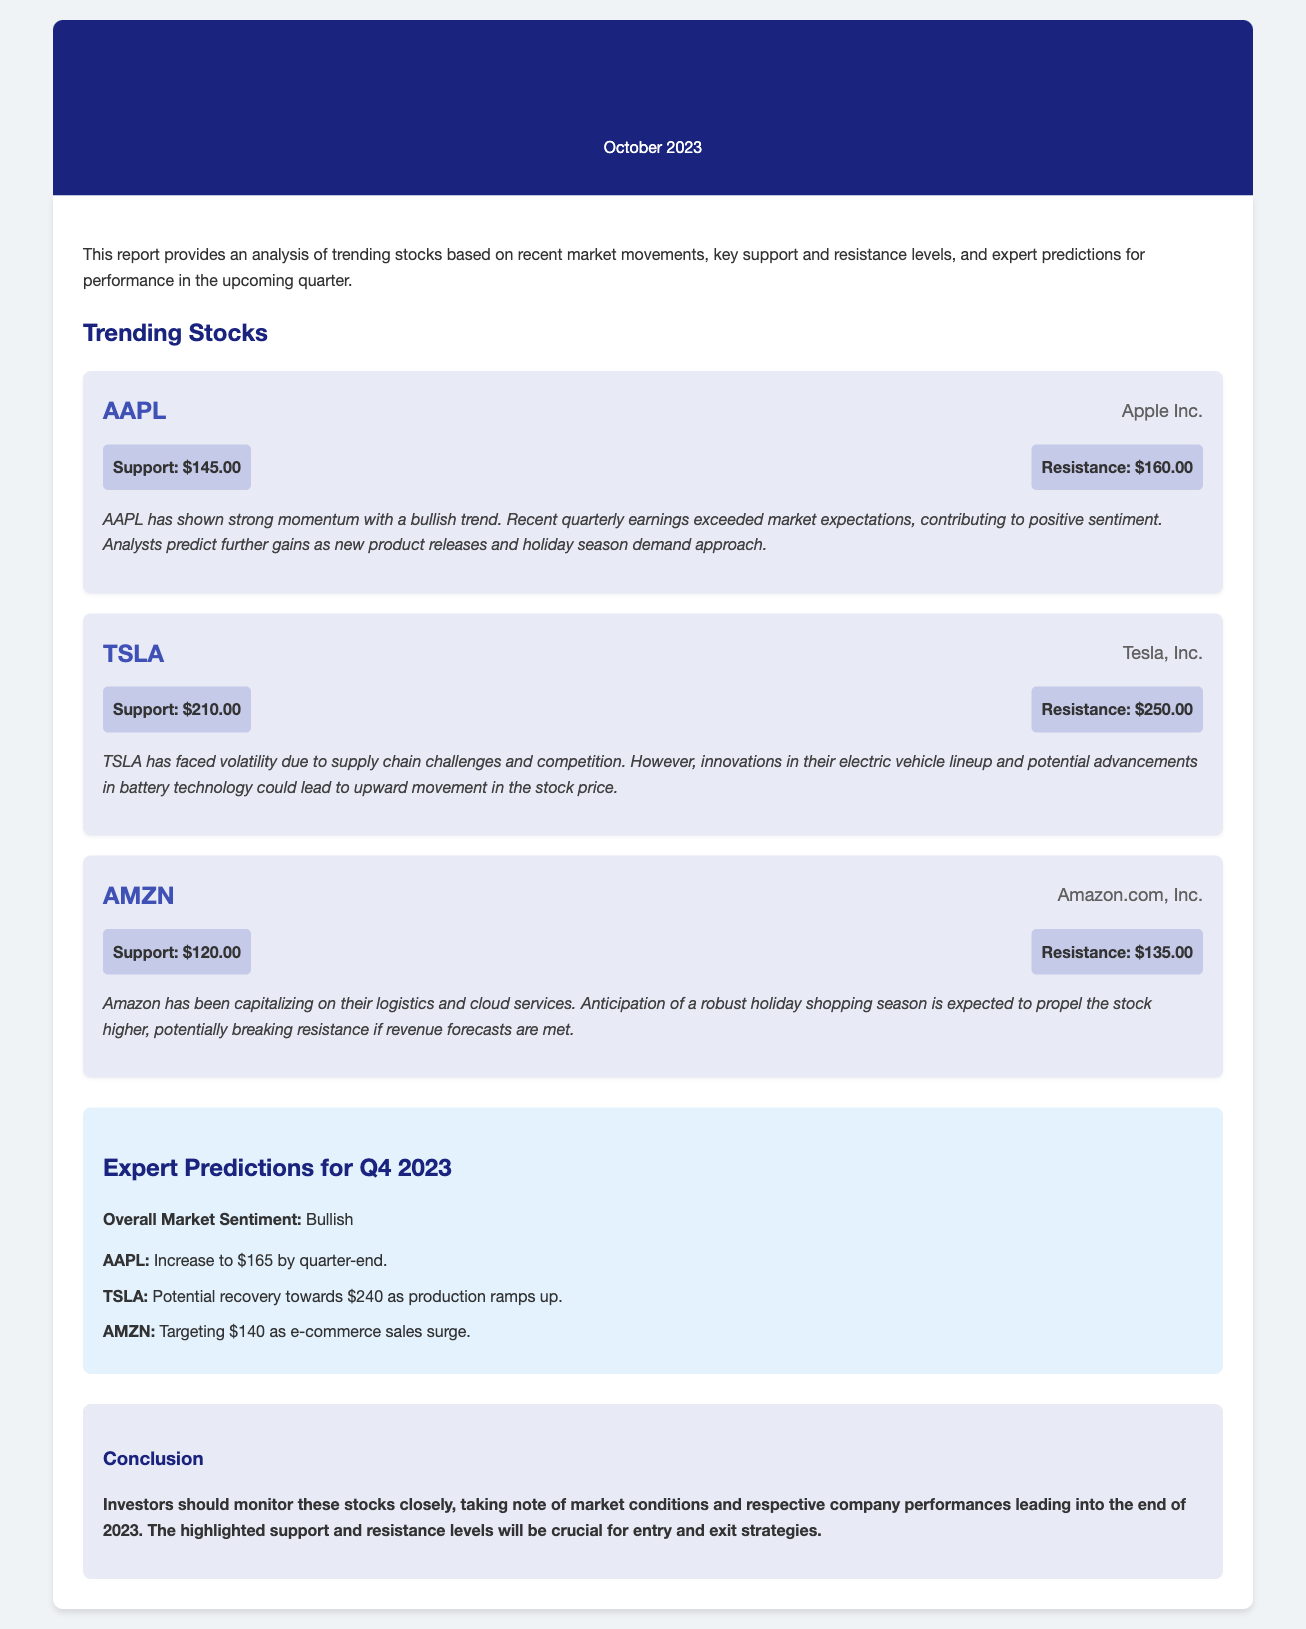what is the support level for AAPL? The support level for AAPL is specifically stated in the document as $145.00.
Answer: $145.00 what is the resistance level for TSLA? The resistance level for TSLA is explicitly mentioned as $250.00 in the document.
Answer: $250.00 how much is the predicted target price for AMZN by the end of Q4 2023? The document predicts AMZN will reach $140 as per expert predictions for Q4 2023.
Answer: $140 which stock has a bullish trend according to the analysis? The analysis indicates that AAPL has shown strong momentum with a bullish trend.
Answer: AAPL what is the overall market sentiment for Q4 2023? The document categorizes the overall market sentiment as bullish for Q4 2023.
Answer: Bullish how is TSLA expected to recover according to the predictions? The predictions state that TSLA has the potential recovery towards $240 as production ramps up.
Answer: $240 which company is mentioned as capitalizing on logistics and cloud services? The document specifies that Amazon has been capitalizing on their logistics and cloud services.
Answer: Amazon what is the main exhibition date of this report? The report is dated October 2023, reflecting the time of publication.
Answer: October 2023 what is highlighted as crucial for entry and exit strategies? The support and resistance levels are highlighted as crucial for investors' entry and exit strategies.
Answer: Support and resistance levels 